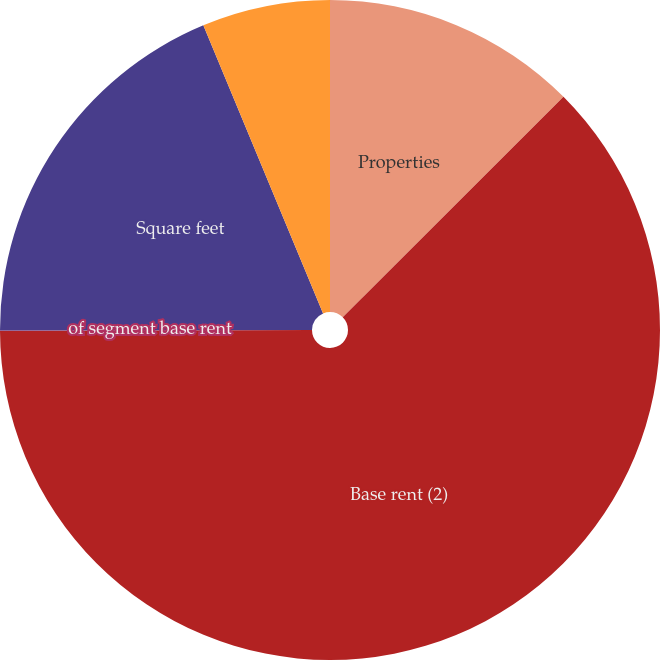<chart> <loc_0><loc_0><loc_500><loc_500><pie_chart><fcel>Properties<fcel>Base rent (2)<fcel>of segment base rent<fcel>Square feet<fcel>of total base rent<nl><fcel>12.51%<fcel>62.44%<fcel>0.03%<fcel>18.75%<fcel>6.27%<nl></chart> 